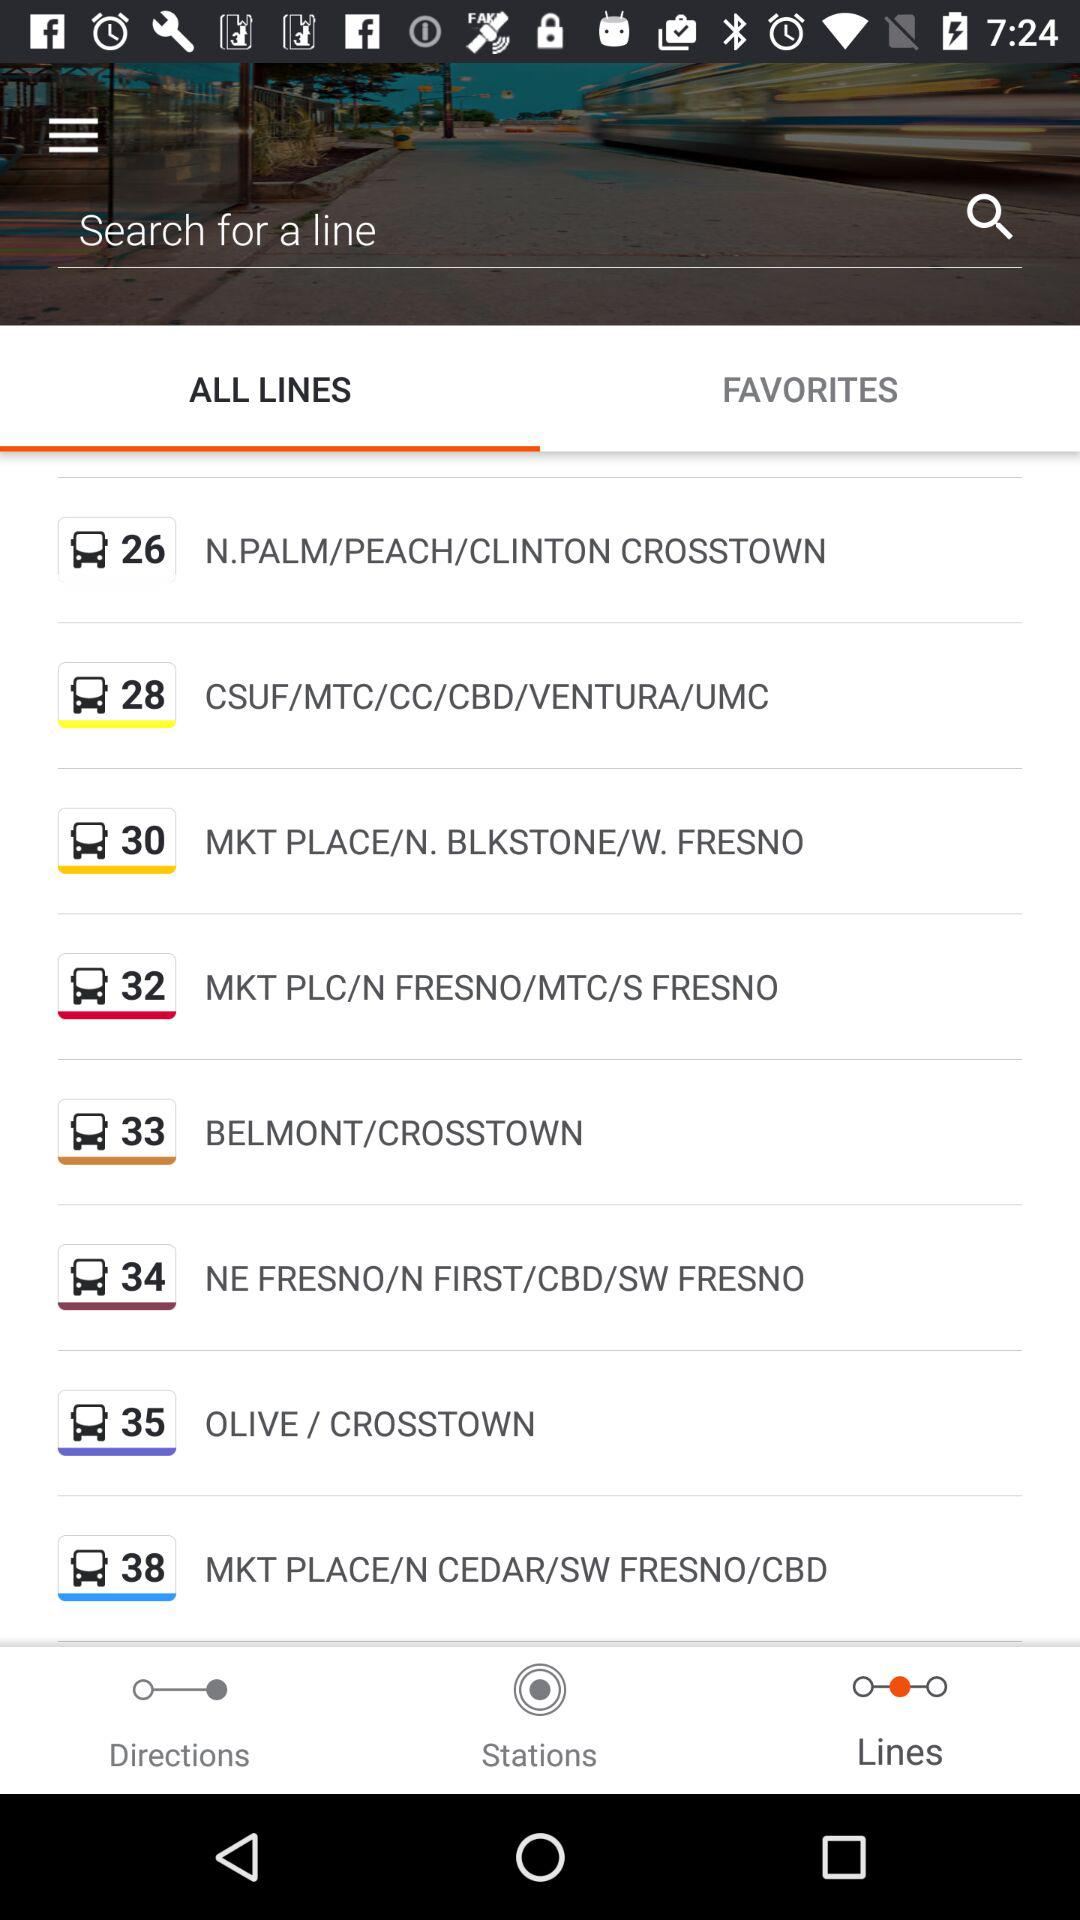What is listed in "FAVORITES"?
When the provided information is insufficient, respond with <no answer>. <no answer> 